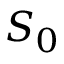<formula> <loc_0><loc_0><loc_500><loc_500>S _ { 0 }</formula> 